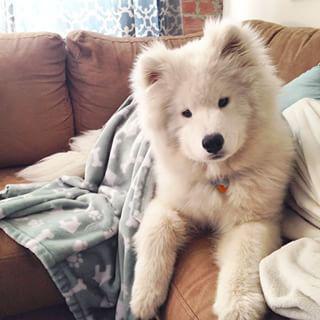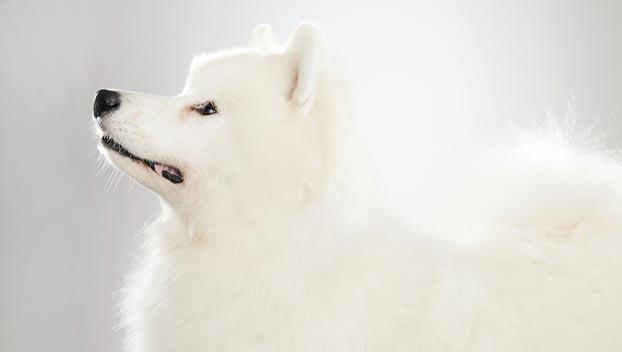The first image is the image on the left, the second image is the image on the right. Assess this claim about the two images: "There is a lone dog with it's mouth open and tongue hanging out.". Correct or not? Answer yes or no. No. 